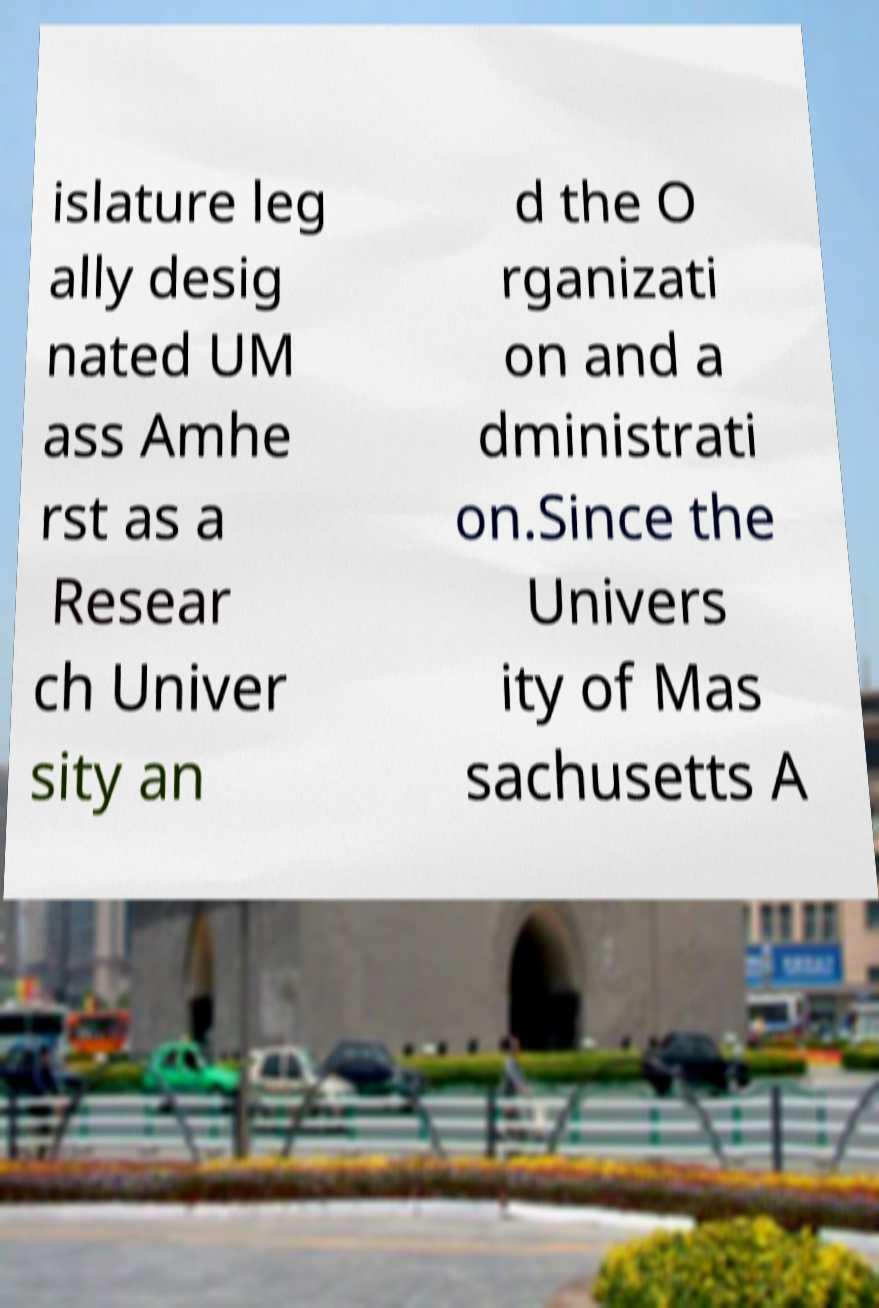Can you accurately transcribe the text from the provided image for me? islature leg ally desig nated UM ass Amhe rst as a Resear ch Univer sity an d the O rganizati on and a dministrati on.Since the Univers ity of Mas sachusetts A 